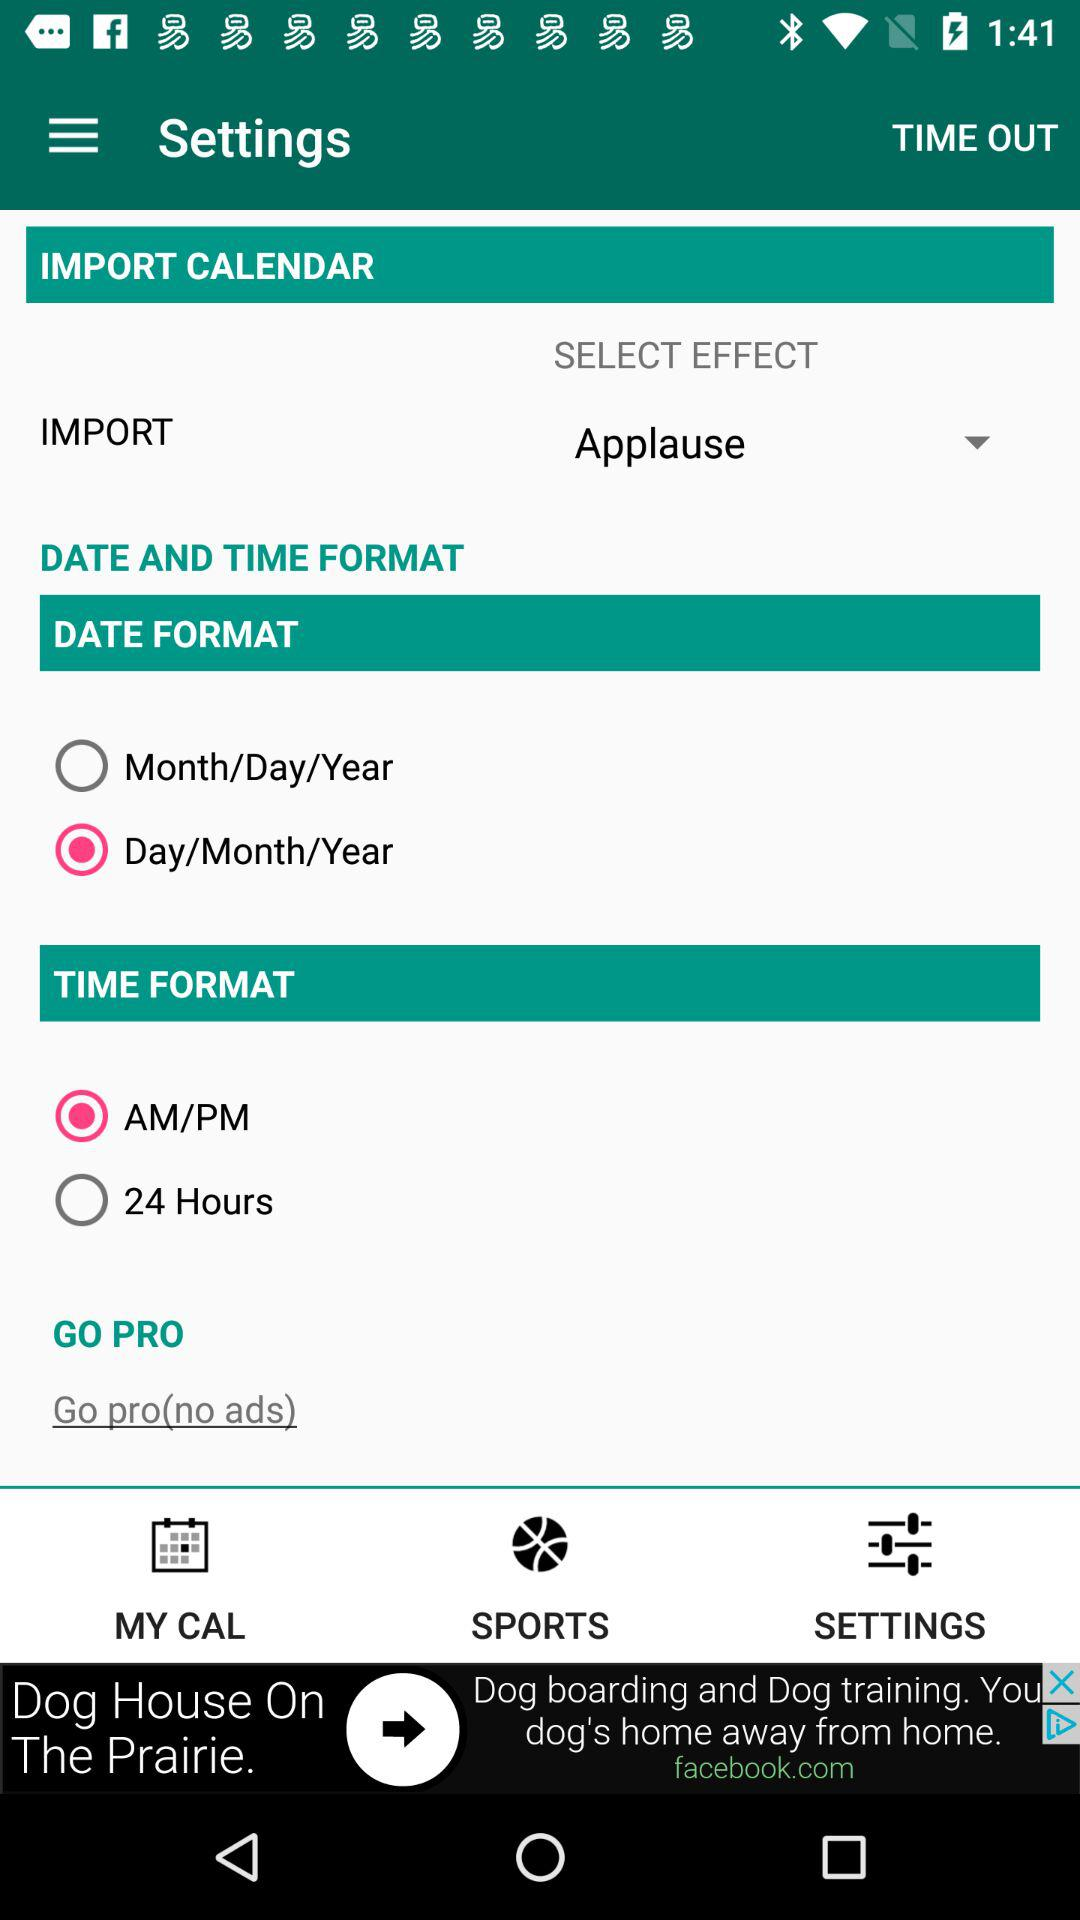What is the selected format for time? The selected format for time is AM/PM. 